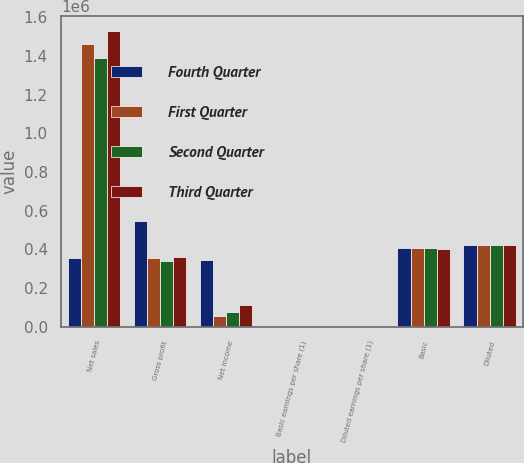Convert chart. <chart><loc_0><loc_0><loc_500><loc_500><stacked_bar_chart><ecel><fcel>Net sales<fcel>Gross profit<fcel>Net income<fcel>Basic earnings per share (1)<fcel>Diluted earnings per share (1)<fcel>Basic<fcel>Diluted<nl><fcel>Fourth Quarter<fcel>355651<fcel>544466<fcel>346688<fcel>0.85<fcel>0.82<fcel>408227<fcel>425034<nl><fcel>First Quarter<fcel>1.46248e+06<fcel>355651<fcel>54147<fcel>0.13<fcel>0.13<fcel>406647<fcel>424777<nl><fcel>Second Quarter<fcel>1.38734e+06<fcel>341046<fcel>76480<fcel>0.19<fcel>0.18<fcel>405268<fcel>424678<nl><fcel>Third Quarter<fcel>1.53035e+06<fcel>360834<fcel>111136<fcel>0.28<fcel>0.26<fcel>403542<fcel>424519<nl></chart> 